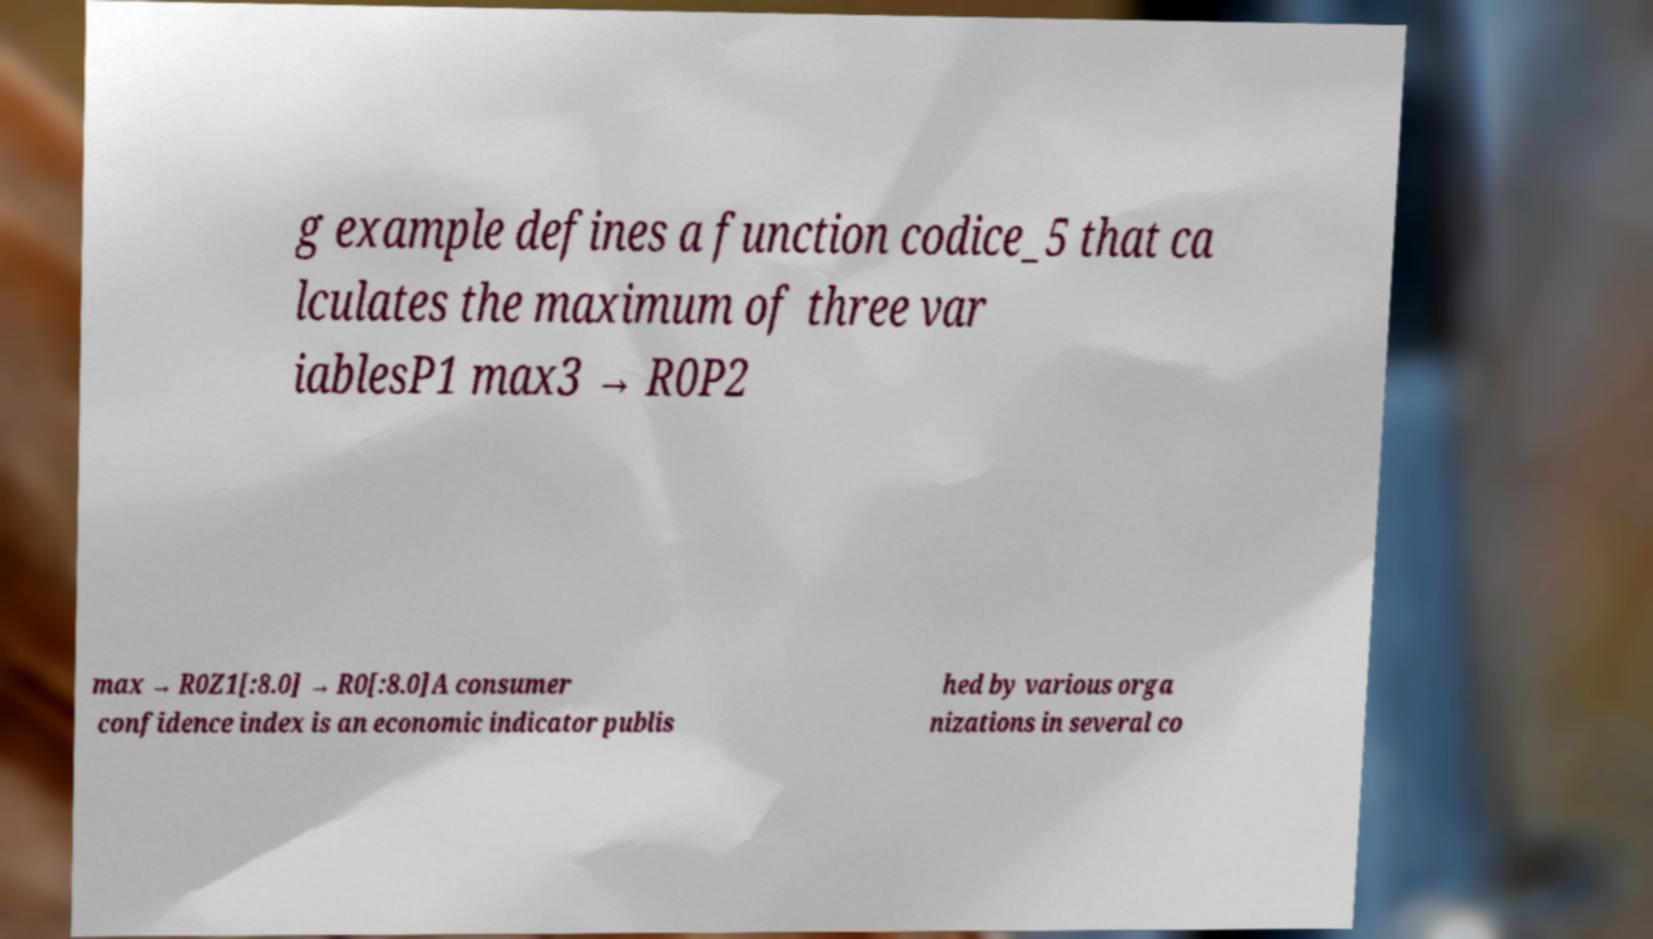Can you accurately transcribe the text from the provided image for me? g example defines a function codice_5 that ca lculates the maximum of three var iablesP1 max3 → R0P2 max → R0Z1[:8.0] → R0[:8.0]A consumer confidence index is an economic indicator publis hed by various orga nizations in several co 